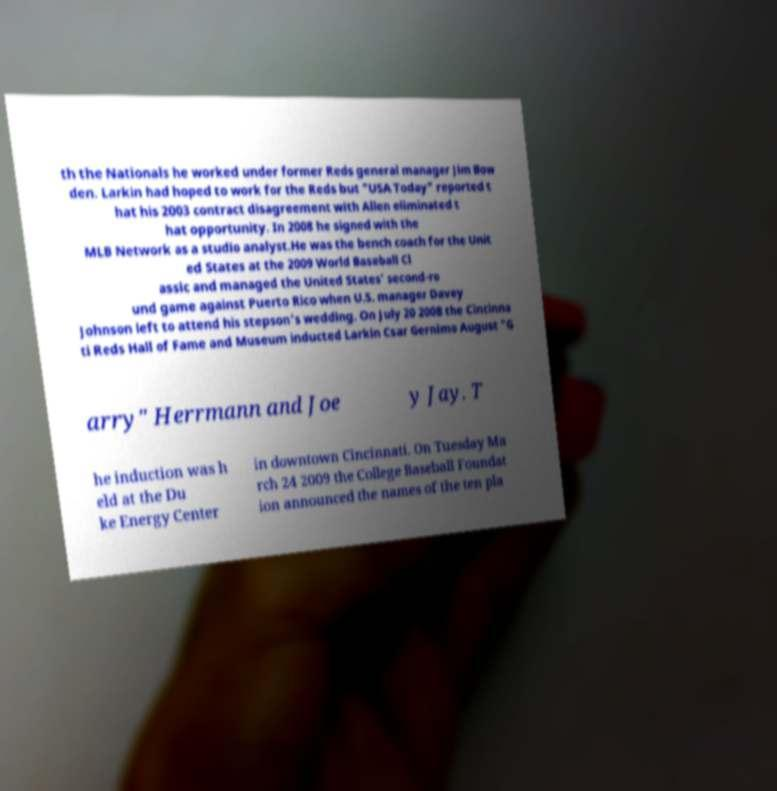For documentation purposes, I need the text within this image transcribed. Could you provide that? th the Nationals he worked under former Reds general manager Jim Bow den. Larkin had hoped to work for the Reds but "USA Today" reported t hat his 2003 contract disagreement with Allen eliminated t hat opportunity. In 2008 he signed with the MLB Network as a studio analyst.He was the bench coach for the Unit ed States at the 2009 World Baseball Cl assic and managed the United States' second-ro und game against Puerto Rico when U.S. manager Davey Johnson left to attend his stepson's wedding. On July 20 2008 the Cincinna ti Reds Hall of Fame and Museum inducted Larkin Csar Gernimo August "G arry" Herrmann and Joe y Jay. T he induction was h eld at the Du ke Energy Center in downtown Cincinnati. On Tuesday Ma rch 24 2009 the College Baseball Foundat ion announced the names of the ten pla 